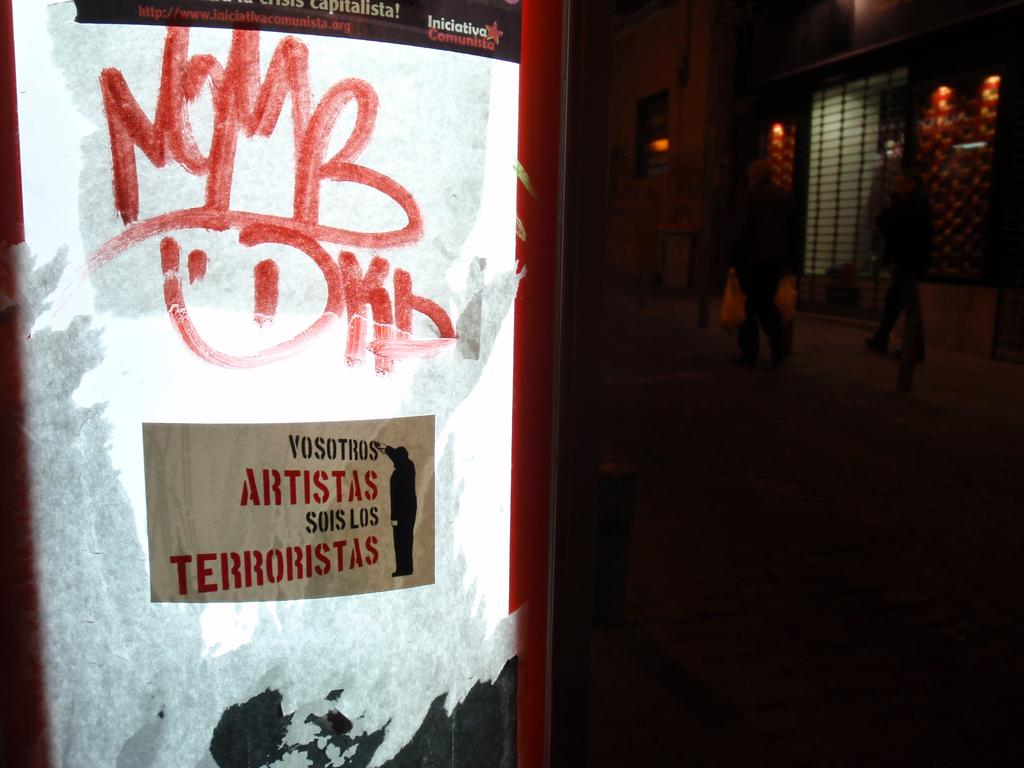<image>
Create a compact narrative representing the image presented. An electronic sign with a sticker that says "Vosotros Artistas sois Los Terroristas" 